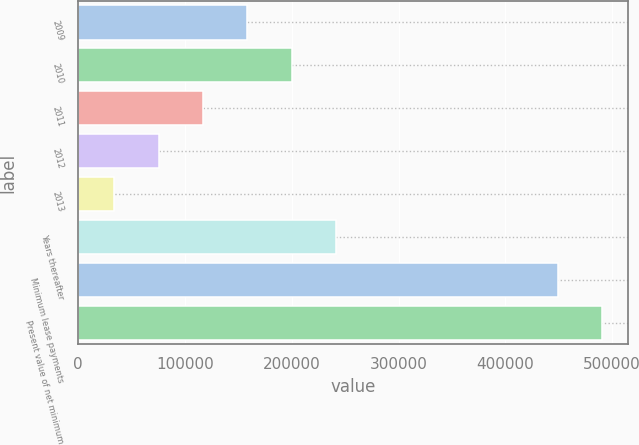<chart> <loc_0><loc_0><loc_500><loc_500><bar_chart><fcel>2009<fcel>2010<fcel>2011<fcel>2012<fcel>2013<fcel>Years thereafter<fcel>Minimum lease payments<fcel>Present value of net minimum<nl><fcel>158482<fcel>199959<fcel>117005<fcel>75527.3<fcel>34050<fcel>241436<fcel>448823<fcel>490300<nl></chart> 